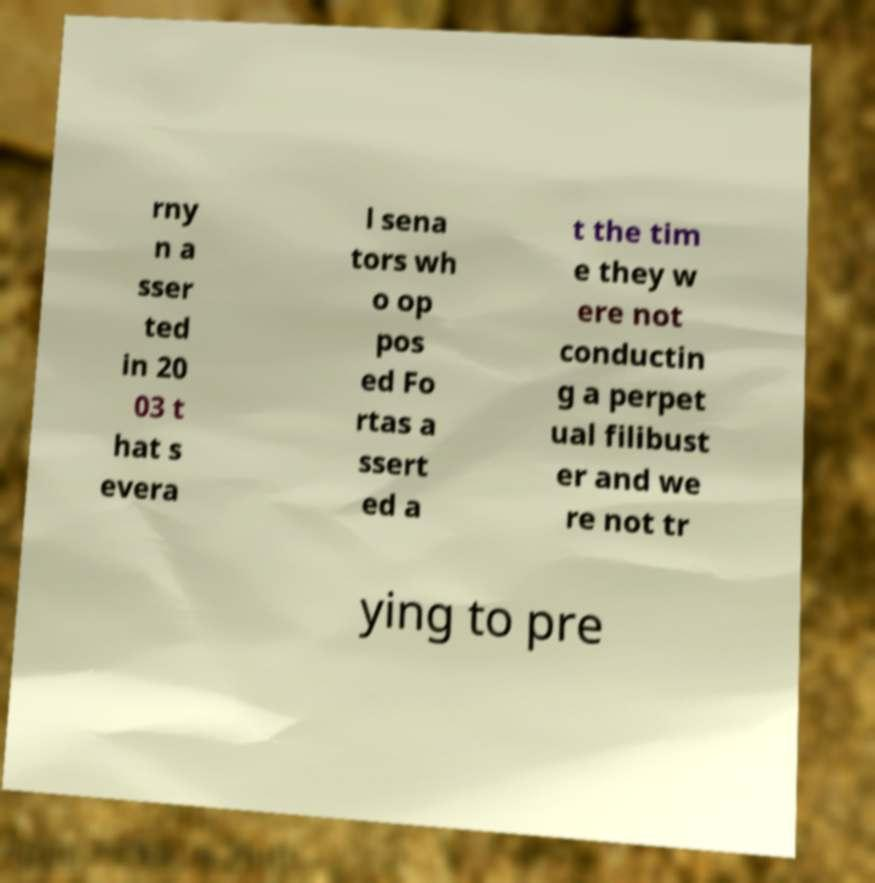Please read and relay the text visible in this image. What does it say? rny n a sser ted in 20 03 t hat s evera l sena tors wh o op pos ed Fo rtas a ssert ed a t the tim e they w ere not conductin g a perpet ual filibust er and we re not tr ying to pre 